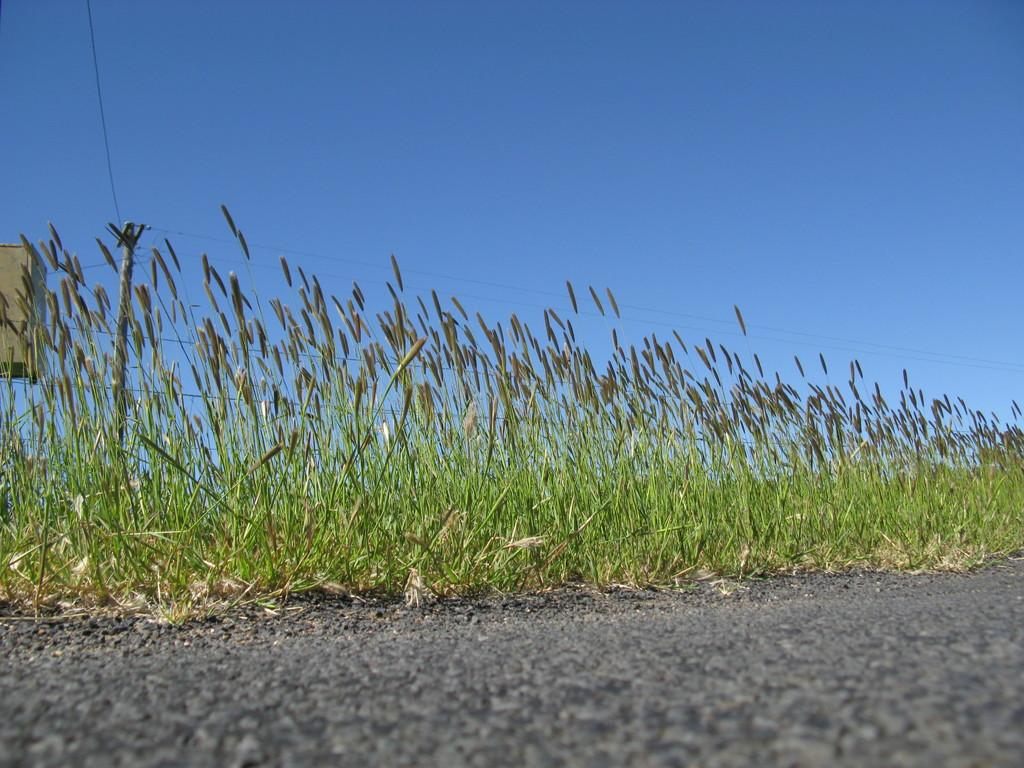What is the main feature of the image? There is a road in the image. What else can be seen in the image besides the road? There are plants and an object visible in the background of the image. What is visible in the background of the image? The sky is visible in the background of the image. What type of idea can be seen in the image? There is no idea present in the image; it is a visual representation of a road, plants, and an object in the background. What does the taste of the plants in the image suggest? The image does not provide any information about the taste of the plants, as taste is a sensory experience that cannot be conveyed through a visual medium. 